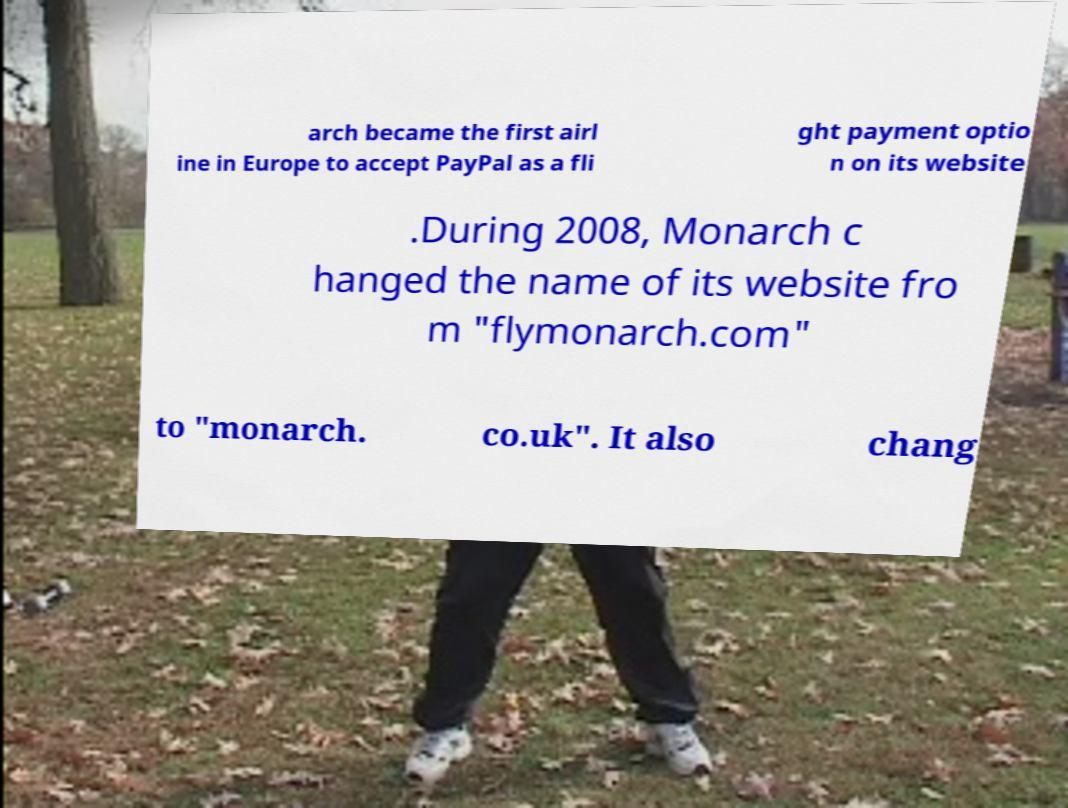What messages or text are displayed in this image? I need them in a readable, typed format. arch became the first airl ine in Europe to accept PayPal as a fli ght payment optio n on its website .During 2008, Monarch c hanged the name of its website fro m "flymonarch.com" to "monarch. co.uk". It also chang 